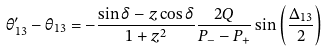<formula> <loc_0><loc_0><loc_500><loc_500>\theta _ { 1 3 } ^ { \prime } - \theta _ { 1 3 } = - \frac { \sin { \delta } - z \cos { \delta } } { 1 + z ^ { 2 } } \frac { 2 Q } { P _ { - } - P _ { + } } \sin { \left ( \frac { \Delta _ { 1 3 } } { 2 } \right ) }</formula> 